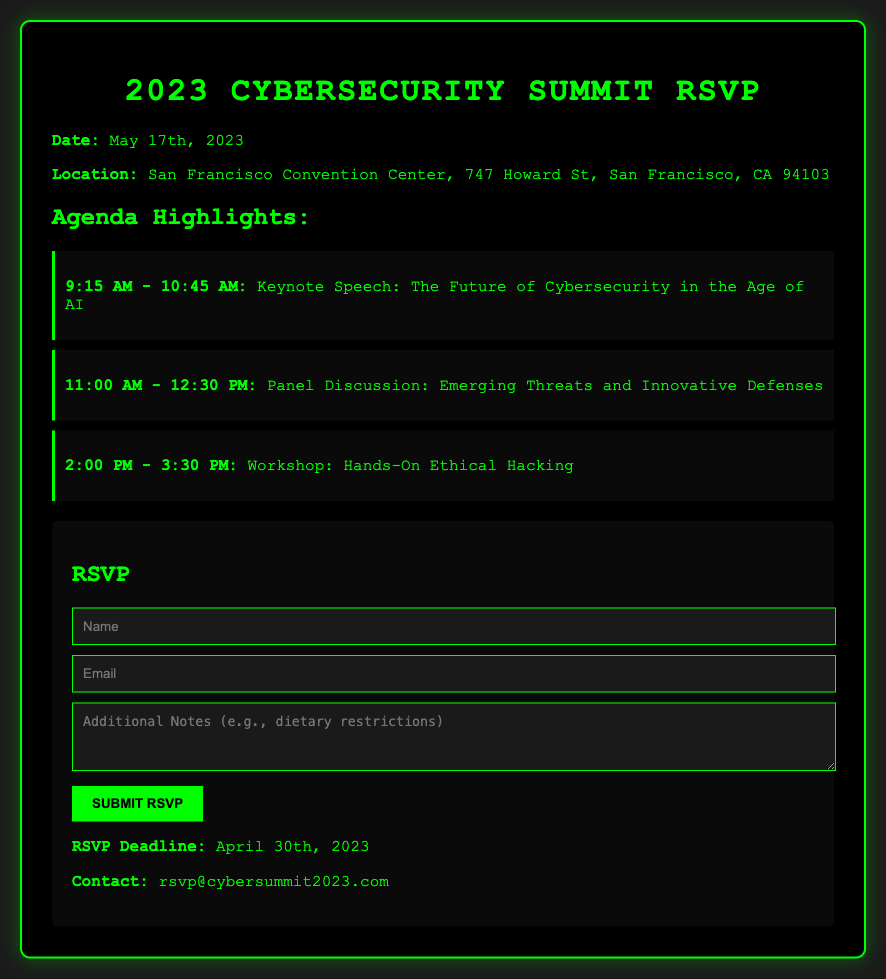what is the date of the event? The date of the event is provided in the document under event details.
Answer: May 17th, 2023 where is the Cybersecurity Summit held? The location of the event is specified in the event details section.
Answer: San Francisco Convention Center, 747 Howard St, San Francisco, CA 94103 what time does the keynote speech start? The starting time for the keynote speech is listed in the agenda highlights.
Answer: 9:15 AM who can be contacted for RSVP queries? The contact email for RSVP-related questions is included in the RSVP section.
Answer: rsvp@cybersummit2023.com what is the RSVP deadline? The deadline for submitting the RSVP is stated in the RSVP section.
Answer: April 30th, 2023 how many panel discussions are mentioned in the agenda? The agenda shows a specific number of panel discussions listed.
Answer: 1 what type of event is scheduled for 2:00 PM? The event type scheduled for 2:00 PM is mentioned in the agenda highlights.
Answer: Workshop what color is the RSVP card's background? The color of the RSVP card's background is detailed in the CSS styles of the document.
Answer: Black 